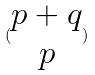<formula> <loc_0><loc_0><loc_500><loc_500>( \begin{matrix} p + q \\ p \end{matrix} )</formula> 